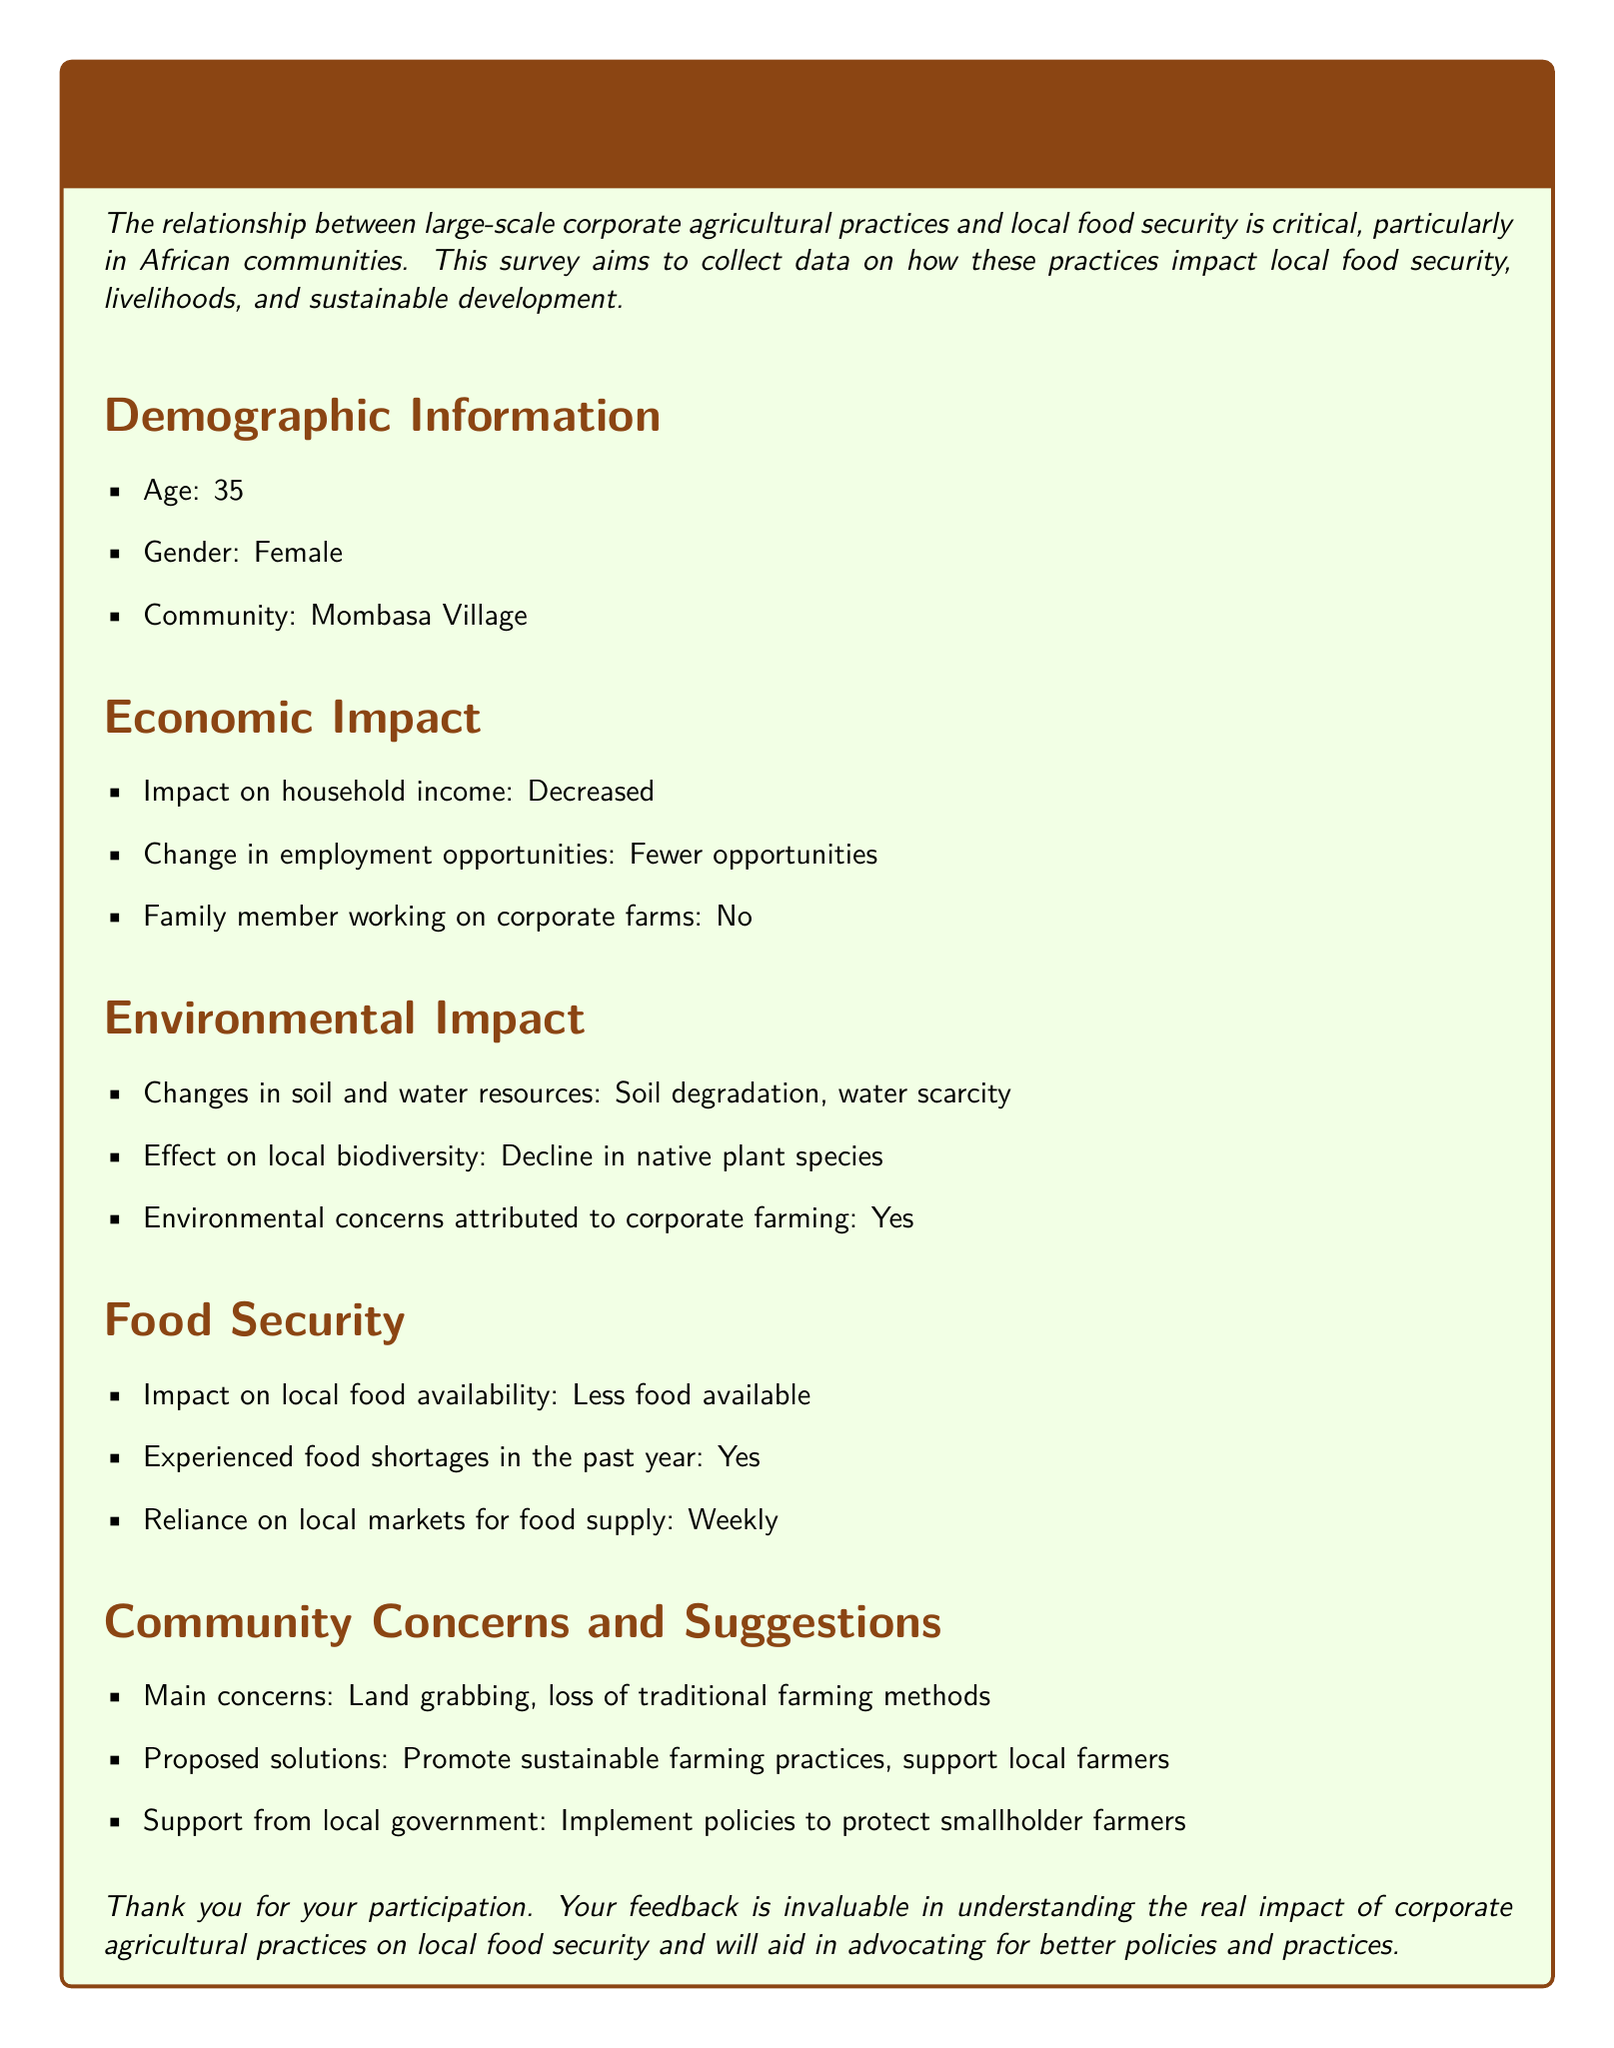what is the respondent's age? The respondent's age is explicitly stated in the demographic section of the survey.
Answer: 35 what is the impact on household income? This information is found in the Economic Impact section of the document, specifically mentioning the effect on household income.
Answer: Decreased what environmental concerns are attributed to corporate farming? This information is located in the Environmental Impact section of the survey that identifies environmental issues linked to corporate practices.
Answer: Yes how has local food availability changed? This information is provided in the Food Security section, detailing the change in food availability for the community.
Answer: Less food available what is the main concern regarding corporate agricultural practices? This is mentioned in the Community Concerns and Suggestions section, focusing on community priorities and worries.
Answer: Land grabbing how often does the respondent rely on local markets for food supply? This information can be found in the Food Security section, which states the frequency of market reliance for food.
Answer: Weekly what is the proposed solution for the issues faced? The document lists suggested solutions in the Community Concerns and Suggestions section for addressing the problems identified.
Answer: Promote sustainable farming practices how many employment opportunities have changed? This is found in the Economic Impact section focusing on the change in job availability as reported by the respondent.
Answer: Fewer opportunities has the respondent experienced food shortages in the past year? This is a direct question answered in the Food Security section, referring to personal experience with food access.
Answer: Yes 